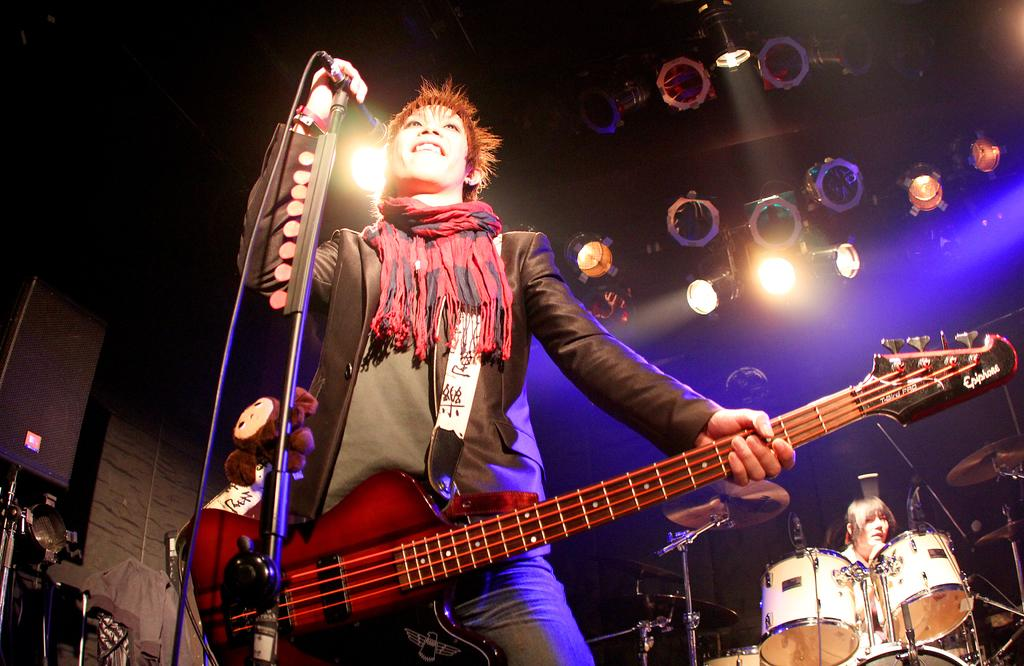What is the person in the image holding in one hand? The person is holding a guitar in one hand. What is the person in the image holding in his other hand? The person is holding a microphone in his other hand. What instrument is the other person in the image playing? The other person is playing drums. Where is the drum player located in relation to the guitarist? The drum player is located to the right of the guitarist. What can be seen above the musicians in the image? There are lights visible above the musicians. What type of eggnog is being served to the musicians in the image? There is no eggnog present in the image; it features musicians holding a guitar, microphone, and playing drums. Is the guitarist's sister also playing an instrument in the image? There is no mention of a sister or any other musicians in the image, only the guitarist and the drum player. 